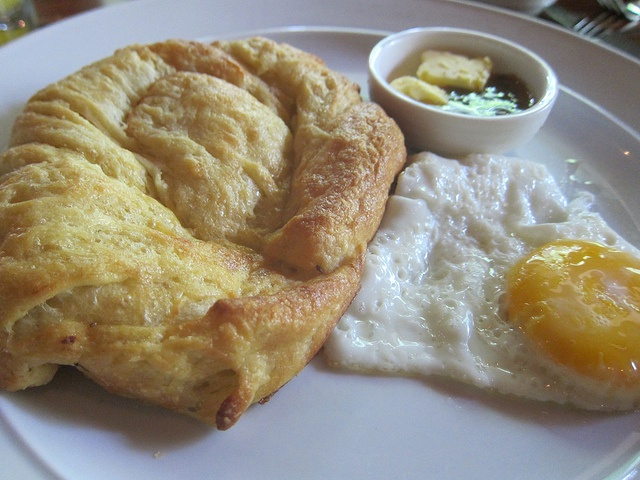Describe the objects in this image and their specific colors. I can see bowl in tan, darkgray, gray, and lightblue tones and fork in tan, black, and gray tones in this image. 